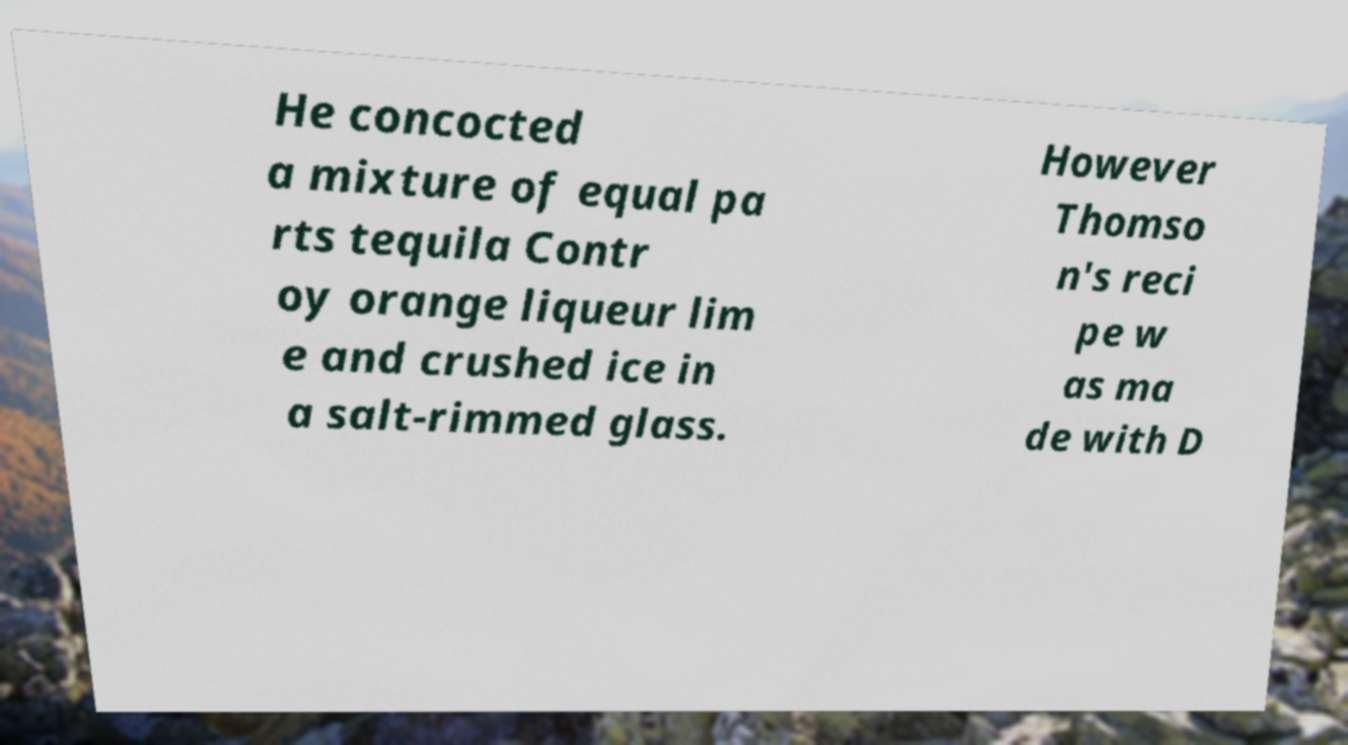Can you accurately transcribe the text from the provided image for me? He concocted a mixture of equal pa rts tequila Contr oy orange liqueur lim e and crushed ice in a salt-rimmed glass. However Thomso n's reci pe w as ma de with D 